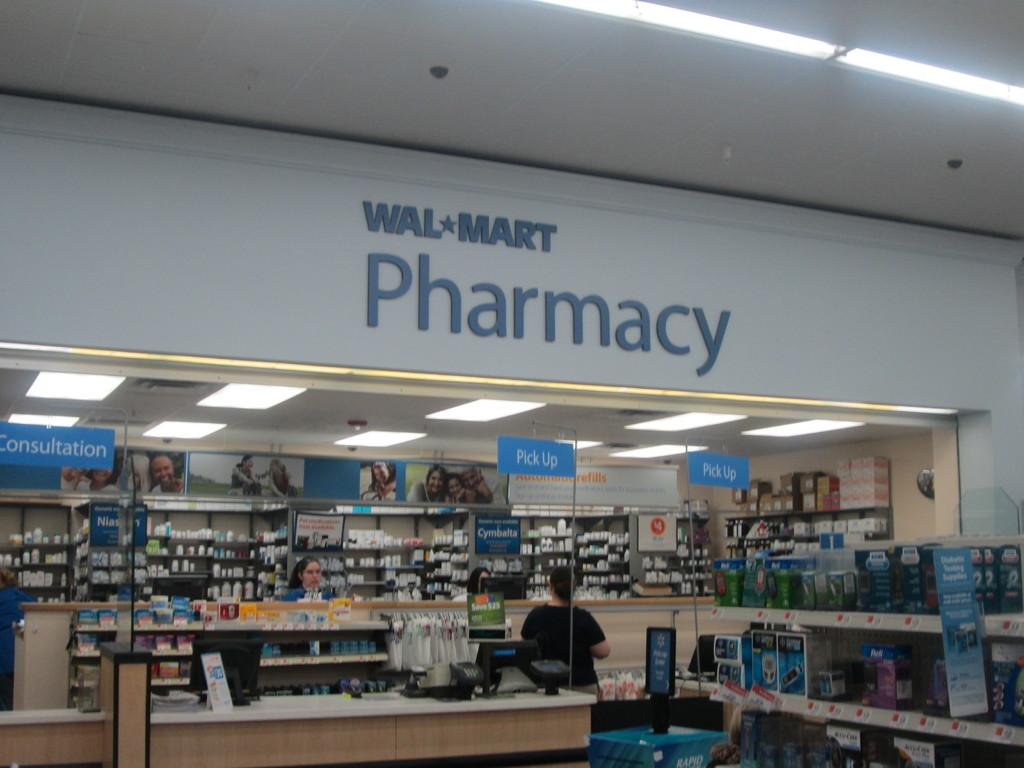Provide a one-sentence caption for the provided image. A woman standing at the Wal Mart Pharmacy counter. 